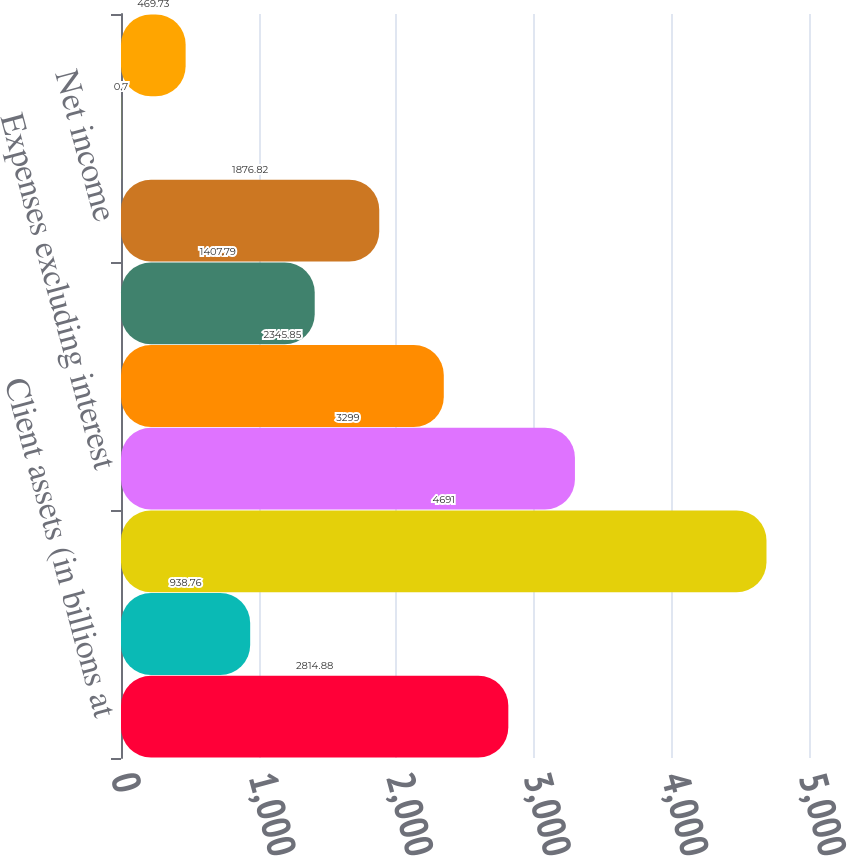Convert chart. <chart><loc_0><loc_0><loc_500><loc_500><bar_chart><fcel>Client assets (in billions at<fcel>Clients' daily average trades<fcel>Net revenues<fcel>Expenses excluding interest<fcel>Income before taxes on income<fcel>Taxes on income<fcel>Net income<fcel>Earnings per share - diluted<fcel>Net revenue per average<nl><fcel>2814.88<fcel>938.76<fcel>4691<fcel>3299<fcel>2345.85<fcel>1407.79<fcel>1876.82<fcel>0.7<fcel>469.73<nl></chart> 